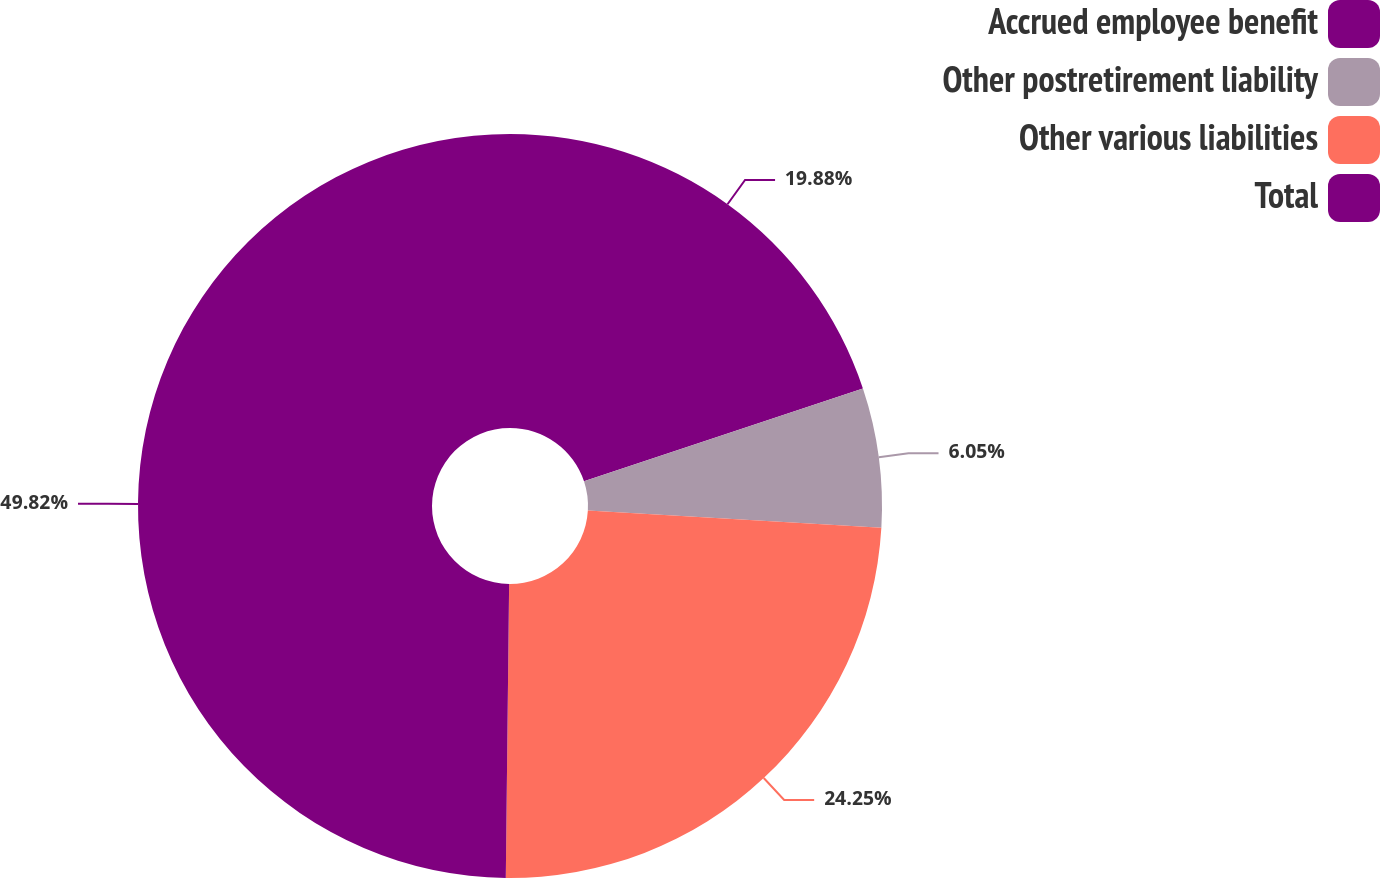<chart> <loc_0><loc_0><loc_500><loc_500><pie_chart><fcel>Accrued employee benefit<fcel>Other postretirement liability<fcel>Other various liabilities<fcel>Total<nl><fcel>19.88%<fcel>6.05%<fcel>24.25%<fcel>49.82%<nl></chart> 